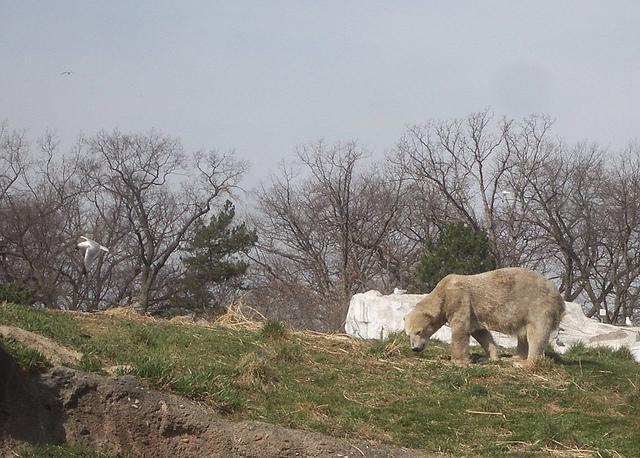How many polar bears are in the photo?
Give a very brief answer. 1. 